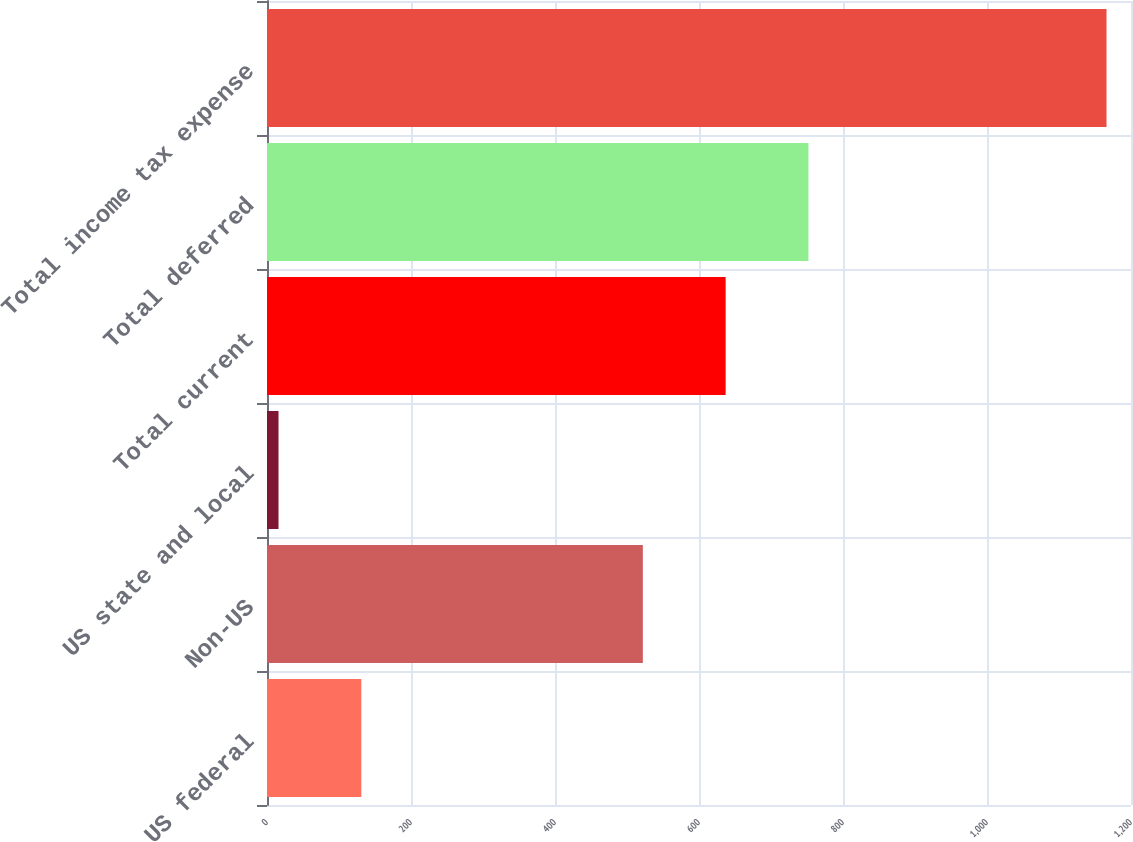Convert chart to OTSL. <chart><loc_0><loc_0><loc_500><loc_500><bar_chart><fcel>US federal<fcel>Non-US<fcel>US state and local<fcel>Total current<fcel>Total deferred<fcel>Total income tax expense<nl><fcel>131<fcel>522<fcel>16<fcel>637<fcel>752<fcel>1166<nl></chart> 